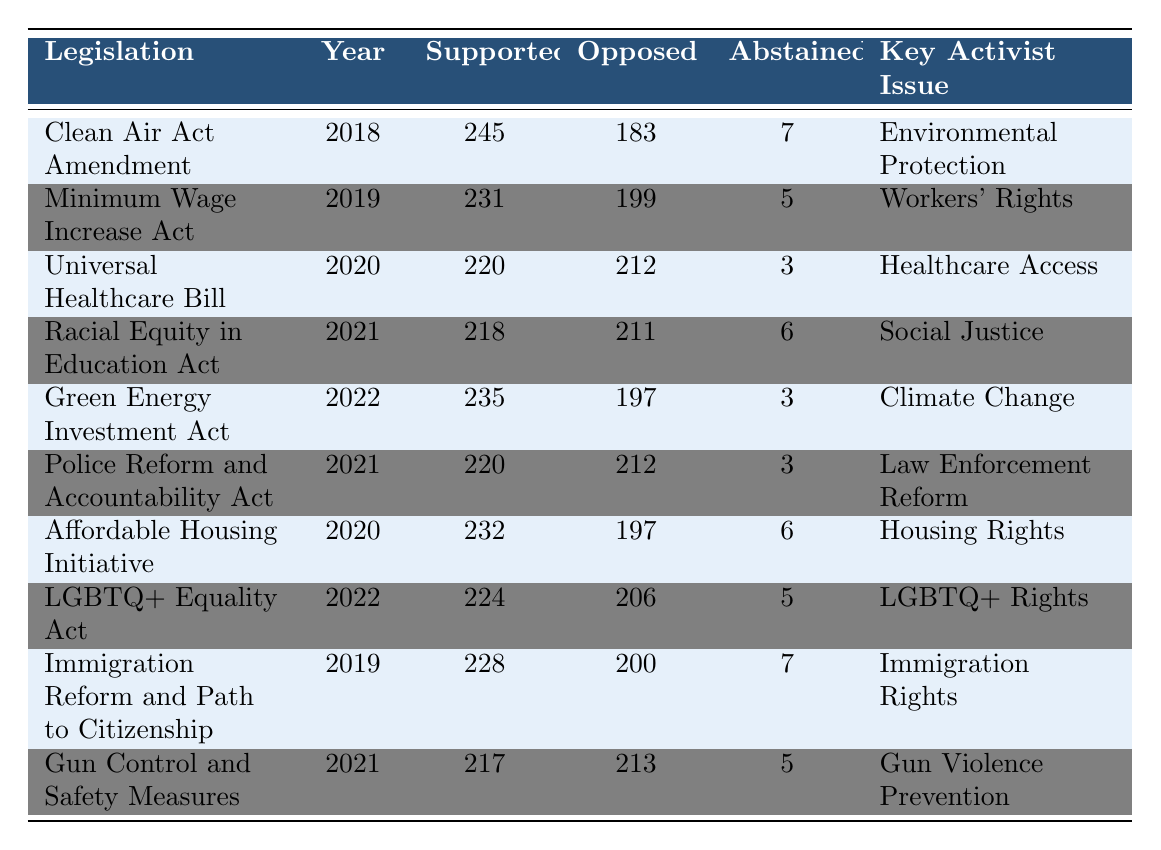What was the total number of lawmakers who supported the Clean Air Act Amendment? In the table, under the "Supported" column for the "Clean Air Act Amendment," the value is 245. This indicates that 245 lawmakers supported this legislation.
Answer: 245 Which year did the Affordable Housing Initiative take place? The table lists the "Affordable Housing Initiative" under the "Year" column, which shows the year as 2020.
Answer: 2020 How many lawmakers opposed the Universal Healthcare Bill? According to the "Universal Healthcare Bill" row, the "Opposed" column indicates 212 lawmakers opposed this bill.
Answer: 212 Was there any legislation in 2021 that had more supporters than opponents? Examining the rows for 2021, the "Racial Equity in Education Act" had 218 supporters and 211 opponents, meaning it had more supporters than opponents.
Answer: Yes What is the difference between the number of supporters and opponents for the Gun Control and Safety Measures legislation? The "Gun Control and Safety Measures" row shows 217 supporters and 213 opponents. The difference is calculated as 217 - 213 = 4.
Answer: 4 Which activist issue had the least number of lawmakers in support for legislation in this table? By comparing the "Supported" values, the "Universal Healthcare Bill" has 220, which is the least number of supporters among the activist issues listed in the table.
Answer: Healthcare Access For how many of these pieces of legislation did more than 200 lawmakers oppose? The table shows that in the rows for "Universal Healthcare Bill" (212), "Racial Equity in Education Act" (211), "Police Reform and Accountability Act" (212), and "Gun Control and Safety Measures" (213) all had more than 200 opponents. This totals to 4 legislations.
Answer: 4 What percentage of lawmakers supported the Minimum Wage Increase Act compared to those who opposed it? The "Minimum Wage Increase Act" has 231 supporters and 199 opponents. To calculate the percentage of supporters, we use the formula: (231 / (231 + 199)) * 100, which equals approximately 53.7%.
Answer: 53.7% Which activist issue had the highest number of supporters in 2022? The legislation in 2022 are "Green Energy Investment Act" with 235 supporters and "LGBTQ+ Equality Act" with 224 supporters. Thus, "Green Energy Investment Act" had the highest number of supporters.
Answer: Climate Change How many total lawmakers abstained from voting on the legislation listed for 2021? From the table, the "Racial Equity in Education Act" had 6 abstentions and the "Police Reform and Accountability Act" had 3 abstentions, adding these gives a total of 9 abstentions for 2021.
Answer: 9 